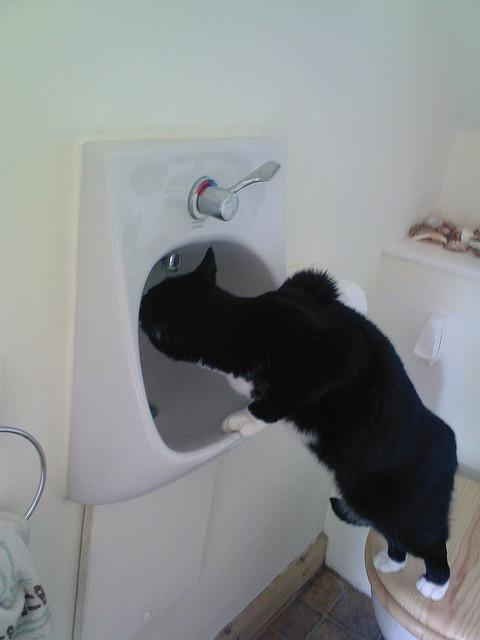How many toilets can you see?
Give a very brief answer. 2. 